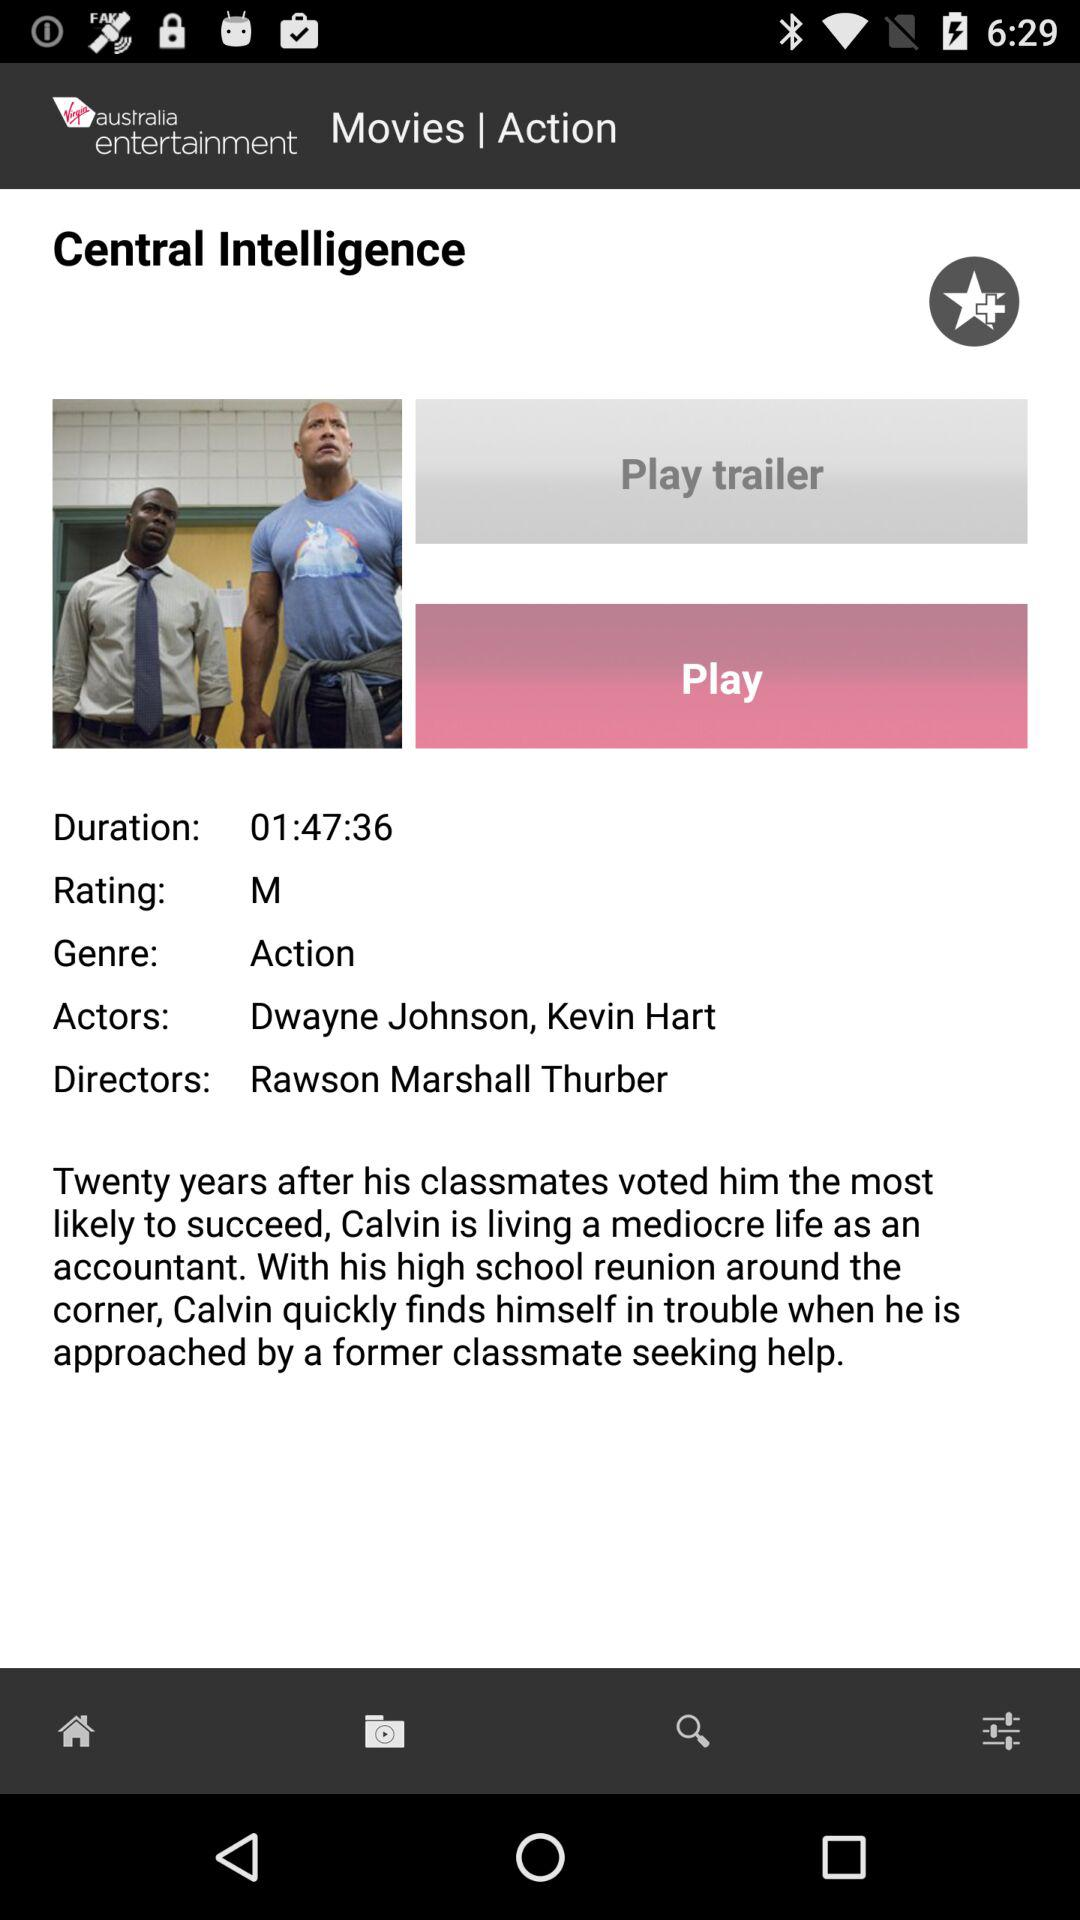When was "Central Intelligence" published?
When the provided information is insufficient, respond with <no answer>. <no answer> 